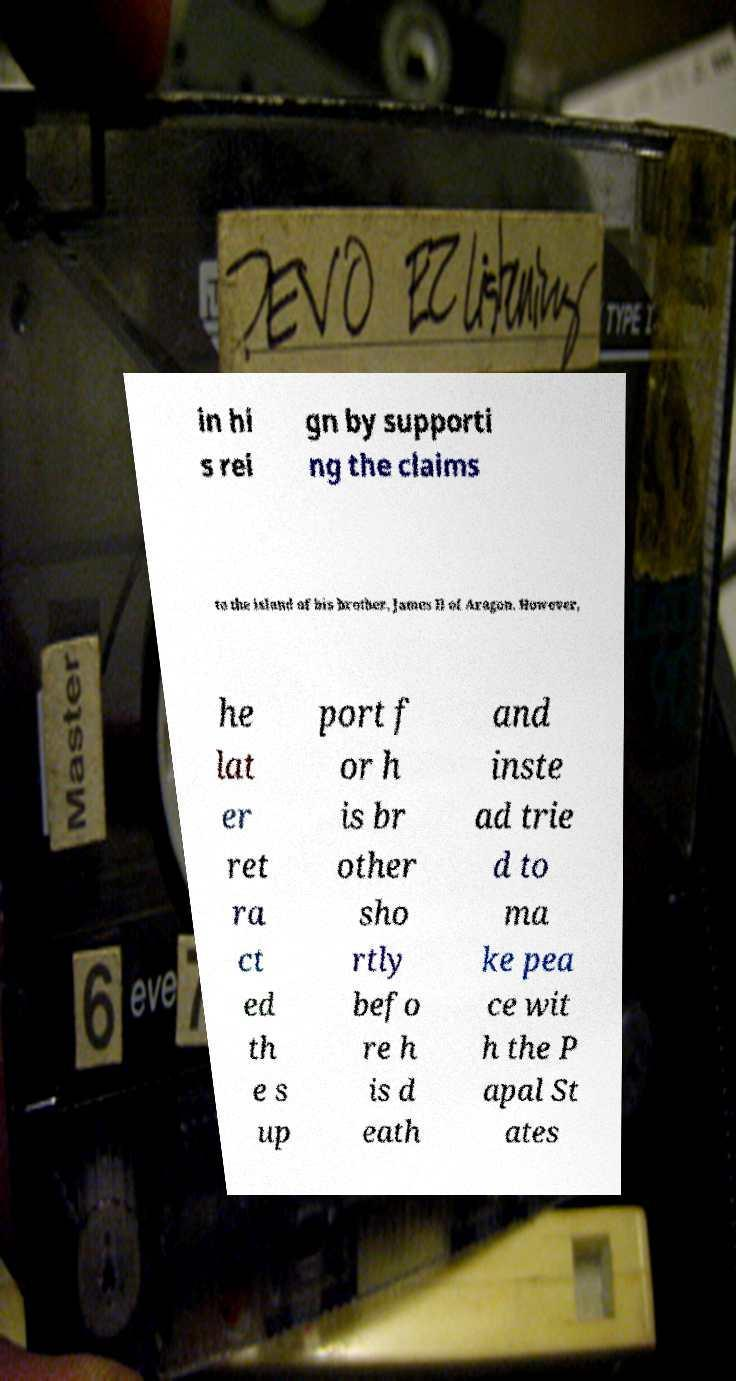Please read and relay the text visible in this image. What does it say? in hi s rei gn by supporti ng the claims to the island of his brother, James II of Aragon. However, he lat er ret ra ct ed th e s up port f or h is br other sho rtly befo re h is d eath and inste ad trie d to ma ke pea ce wit h the P apal St ates 